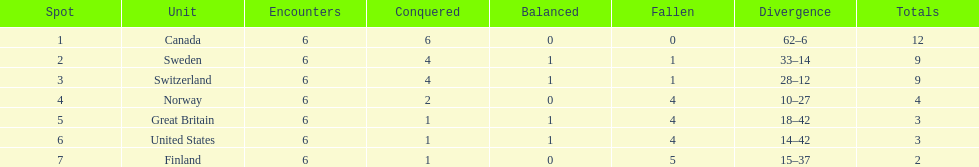How many teams won only 1 match? 3. 